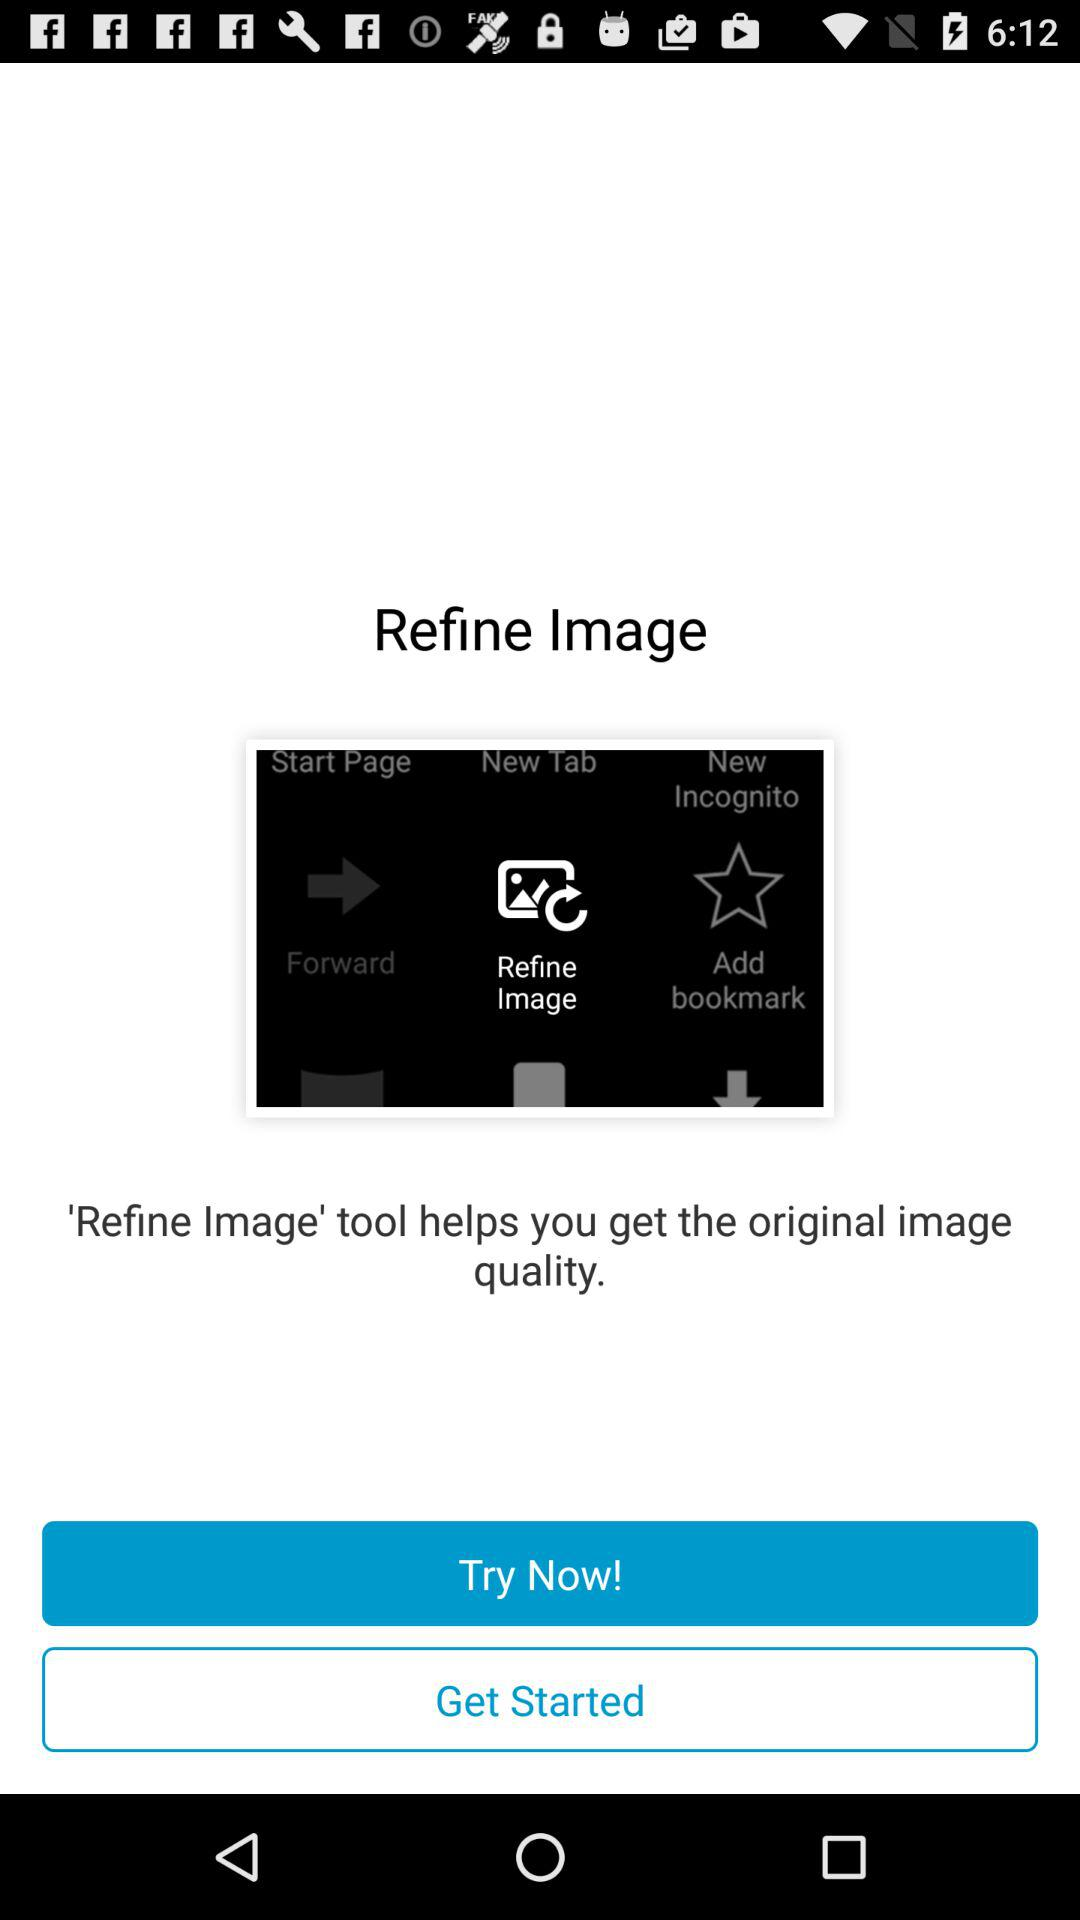What does the refine image tool do? The refine image tool helps you get the original image quality. 